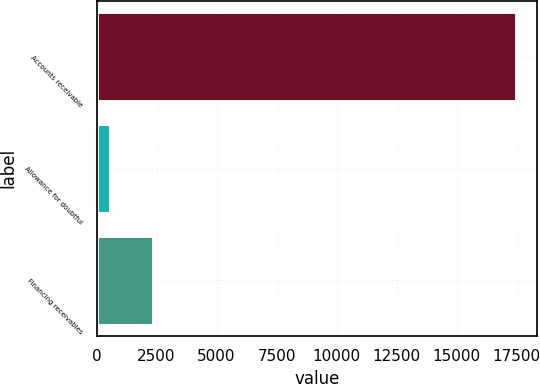Convert chart. <chart><loc_0><loc_0><loc_500><loc_500><bar_chart><fcel>Accounts receivable<fcel>Allowance for doubtful<fcel>Financing receivables<nl><fcel>17481<fcel>553<fcel>2355<nl></chart> 